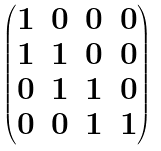<formula> <loc_0><loc_0><loc_500><loc_500>\begin{pmatrix} 1 & 0 & 0 & 0 \\ 1 & 1 & 0 & 0 \\ 0 & 1 & 1 & 0 \\ 0 & 0 & 1 & 1 \end{pmatrix}</formula> 